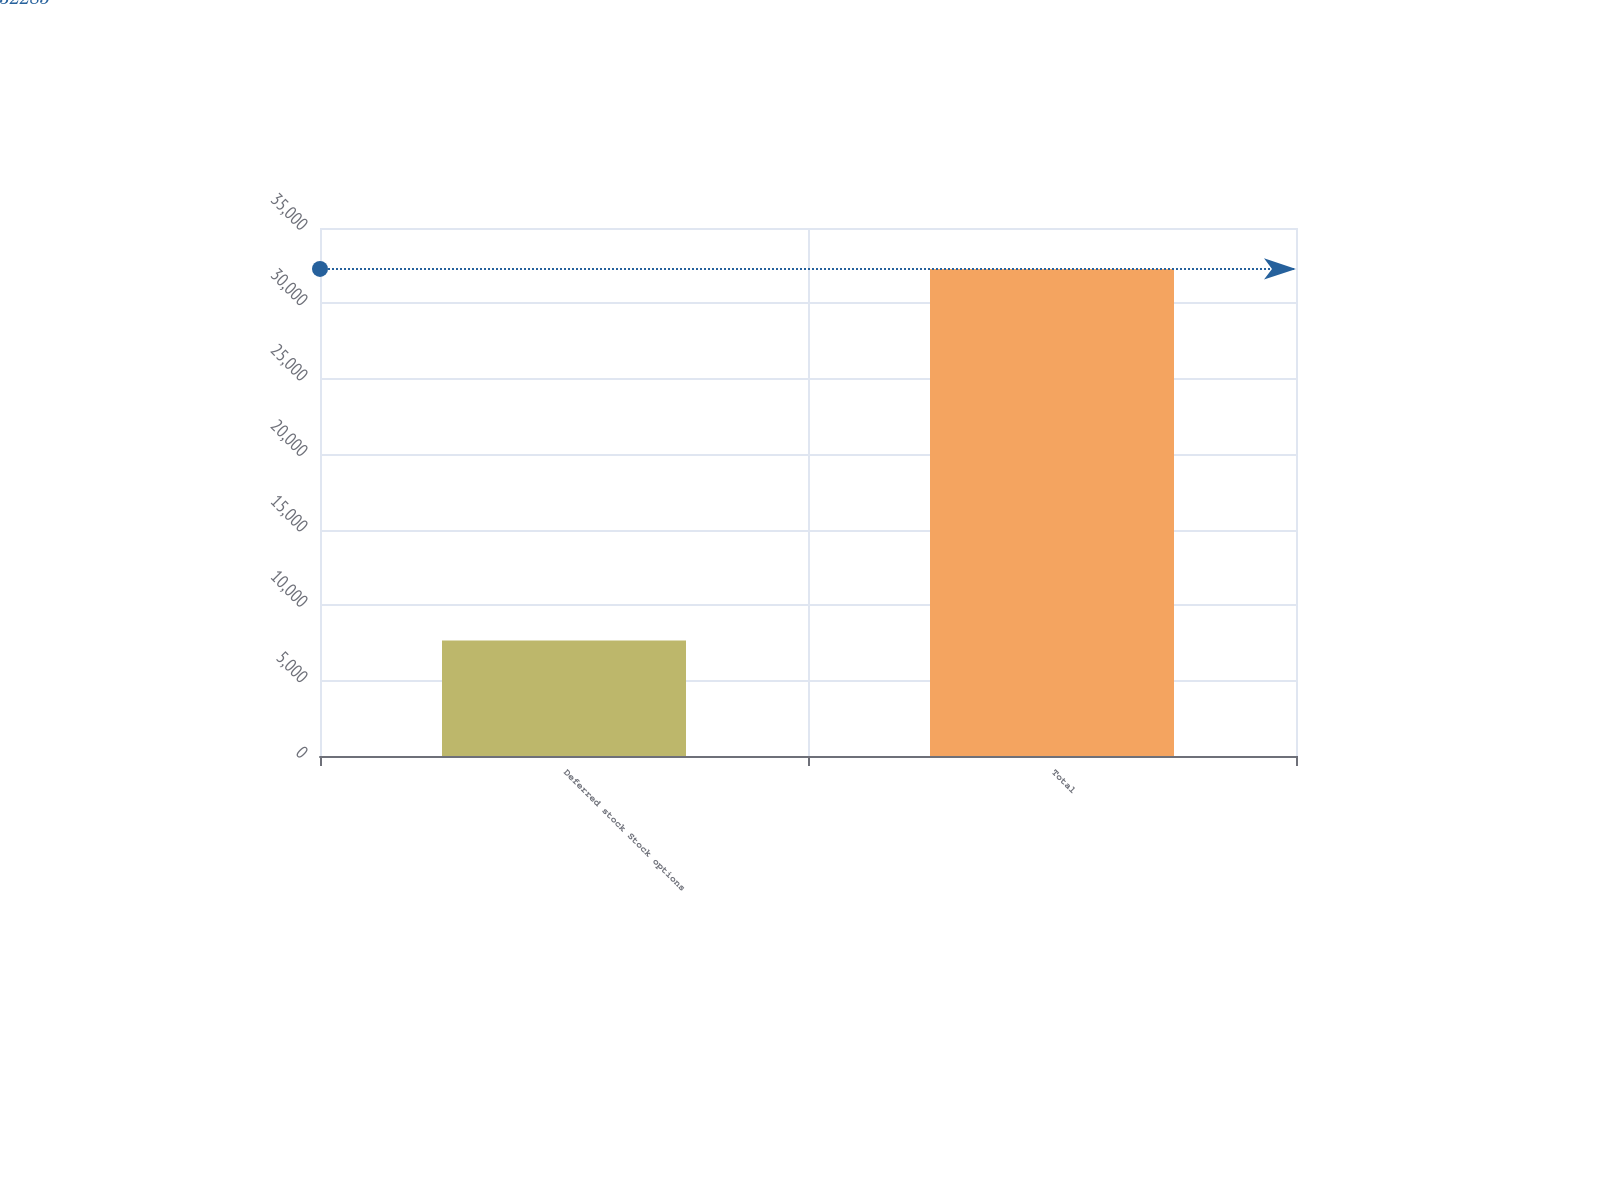Convert chart. <chart><loc_0><loc_0><loc_500><loc_500><bar_chart><fcel>Deferred stock Stock options<fcel>Total<nl><fcel>7653<fcel>32285<nl></chart> 